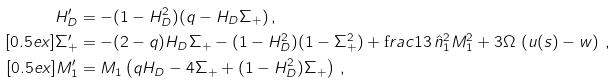<formula> <loc_0><loc_0><loc_500><loc_500>H _ { D } ^ { \prime } & = - ( 1 - H _ { D } ^ { 2 } ) ( q - H _ { D } \Sigma _ { + } ) \, , \\ [ 0 . 5 e x ] \Sigma _ { + } ^ { \prime } & = - ( 2 - q ) H _ { D } \Sigma _ { + } - ( 1 - H _ { D } ^ { 2 } ) ( 1 - \Sigma _ { + } ^ { 2 } ) + \text  frac{1} { 3 } \, \hat { n } _ { 1 } ^ { 2 } M _ { 1 } ^ { 2 } + 3 \Omega \, \left ( u ( s ) - w \right ) \, , \\ [ 0 . 5 e x ] M _ { 1 } ^ { \prime } & = M _ { 1 } \left ( q H _ { D } - 4 \Sigma _ { + } + ( 1 - H _ { D } ^ { 2 } ) \Sigma _ { + } \right ) \, ,</formula> 